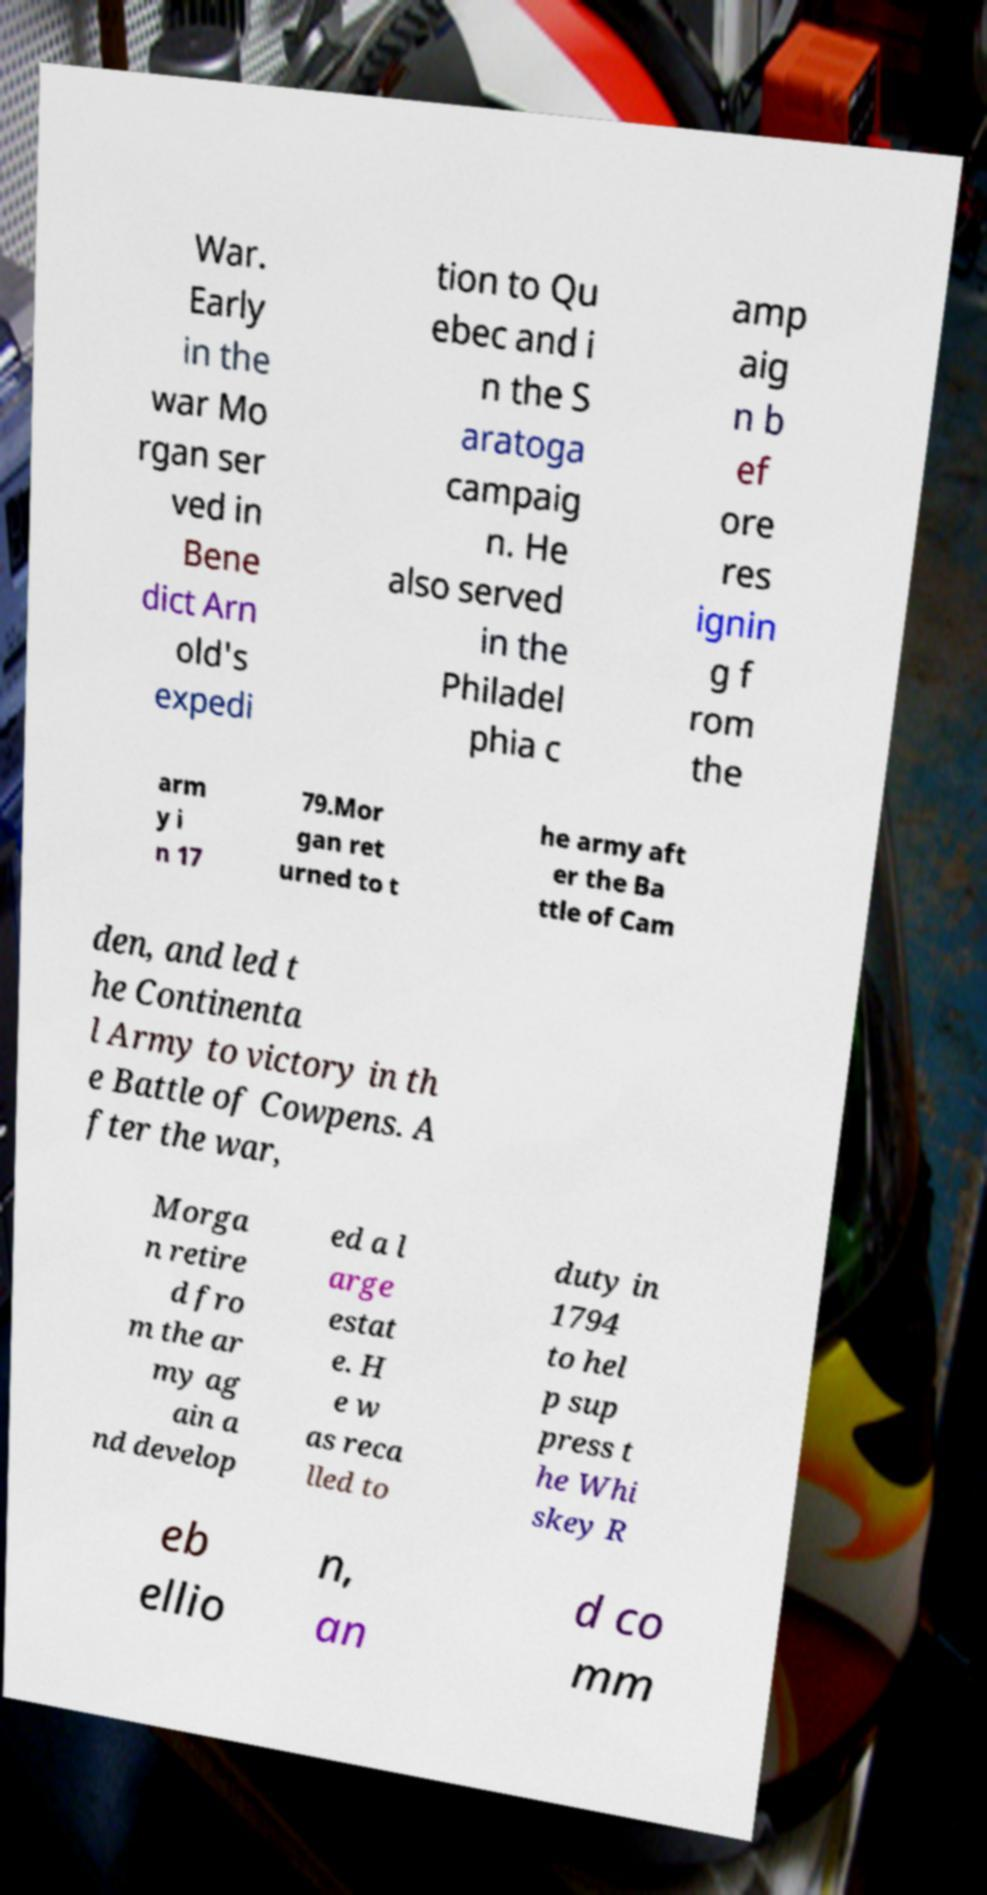Can you read and provide the text displayed in the image?This photo seems to have some interesting text. Can you extract and type it out for me? War. Early in the war Mo rgan ser ved in Bene dict Arn old's expedi tion to Qu ebec and i n the S aratoga campaig n. He also served in the Philadel phia c amp aig n b ef ore res ignin g f rom the arm y i n 17 79.Mor gan ret urned to t he army aft er the Ba ttle of Cam den, and led t he Continenta l Army to victory in th e Battle of Cowpens. A fter the war, Morga n retire d fro m the ar my ag ain a nd develop ed a l arge estat e. H e w as reca lled to duty in 1794 to hel p sup press t he Whi skey R eb ellio n, an d co mm 